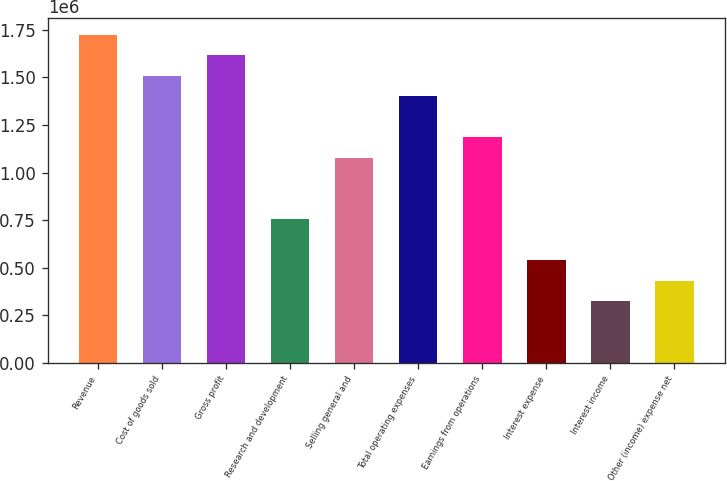Convert chart. <chart><loc_0><loc_0><loc_500><loc_500><bar_chart><fcel>Revenue<fcel>Cost of goods sold<fcel>Gross profit<fcel>Research and development<fcel>Selling general and<fcel>Total operating expenses<fcel>Earnings from operations<fcel>Interest expense<fcel>Interest income<fcel>Other (income) expense net<nl><fcel>1.72316e+06<fcel>1.50776e+06<fcel>1.61546e+06<fcel>753882<fcel>1.07697e+06<fcel>1.40007e+06<fcel>1.18467e+06<fcel>538488<fcel>323093<fcel>430790<nl></chart> 